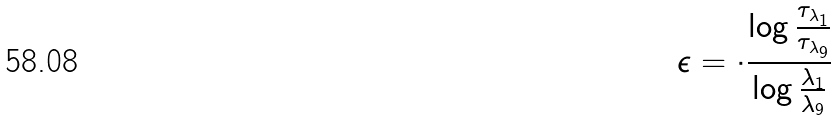Convert formula to latex. <formula><loc_0><loc_0><loc_500><loc_500>\epsilon = \cdot \frac { \log \frac { \tau _ { \lambda _ { 1 } } } { \tau _ { \lambda _ { 9 } } } } { \log \frac { \lambda _ { 1 } } { \lambda _ { 9 } } }</formula> 